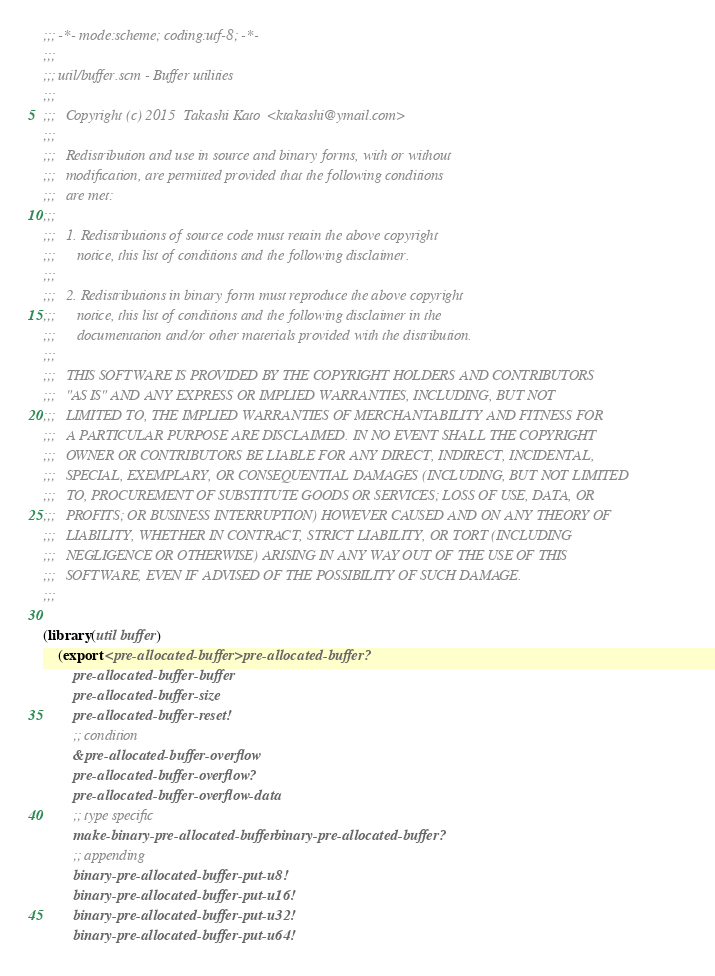Convert code to text. <code><loc_0><loc_0><loc_500><loc_500><_Scheme_>;;; -*- mode:scheme; coding:utf-8; -*-
;;;
;;; util/buffer.scm - Buffer utilities
;;;  
;;;   Copyright (c) 2015  Takashi Kato  <ktakashi@ymail.com>
;;;   
;;;   Redistribution and use in source and binary forms, with or without
;;;   modification, are permitted provided that the following conditions
;;;   are met:
;;;   
;;;   1. Redistributions of source code must retain the above copyright
;;;      notice, this list of conditions and the following disclaimer.
;;;  
;;;   2. Redistributions in binary form must reproduce the above copyright
;;;      notice, this list of conditions and the following disclaimer in the
;;;      documentation and/or other materials provided with the distribution.
;;;  
;;;   THIS SOFTWARE IS PROVIDED BY THE COPYRIGHT HOLDERS AND CONTRIBUTORS
;;;   "AS IS" AND ANY EXPRESS OR IMPLIED WARRANTIES, INCLUDING, BUT NOT
;;;   LIMITED TO, THE IMPLIED WARRANTIES OF MERCHANTABILITY AND FITNESS FOR
;;;   A PARTICULAR PURPOSE ARE DISCLAIMED. IN NO EVENT SHALL THE COPYRIGHT
;;;   OWNER OR CONTRIBUTORS BE LIABLE FOR ANY DIRECT, INDIRECT, INCIDENTAL,
;;;   SPECIAL, EXEMPLARY, OR CONSEQUENTIAL DAMAGES (INCLUDING, BUT NOT LIMITED
;;;   TO, PROCUREMENT OF SUBSTITUTE GOODS OR SERVICES; LOSS OF USE, DATA, OR
;;;   PROFITS; OR BUSINESS INTERRUPTION) HOWEVER CAUSED AND ON ANY THEORY OF
;;;   LIABILITY, WHETHER IN CONTRACT, STRICT LIABILITY, OR TORT (INCLUDING
;;;   NEGLIGENCE OR OTHERWISE) ARISING IN ANY WAY OUT OF THE USE OF THIS
;;;   SOFTWARE, EVEN IF ADVISED OF THE POSSIBILITY OF SUCH DAMAGE.
;;;  

(library (util buffer)
    (export <pre-allocated-buffer> pre-allocated-buffer?
	    pre-allocated-buffer-buffer
	    pre-allocated-buffer-size
	    pre-allocated-buffer-reset!
	    ;; condition
	    &pre-allocated-buffer-overflow
	    pre-allocated-buffer-overflow?
	    pre-allocated-buffer-overflow-data
	    ;; type specific
	    make-binary-pre-allocated-buffer binary-pre-allocated-buffer?
	    ;; appending
	    binary-pre-allocated-buffer-put-u8!
	    binary-pre-allocated-buffer-put-u16!
	    binary-pre-allocated-buffer-put-u32!
	    binary-pre-allocated-buffer-put-u64!</code> 